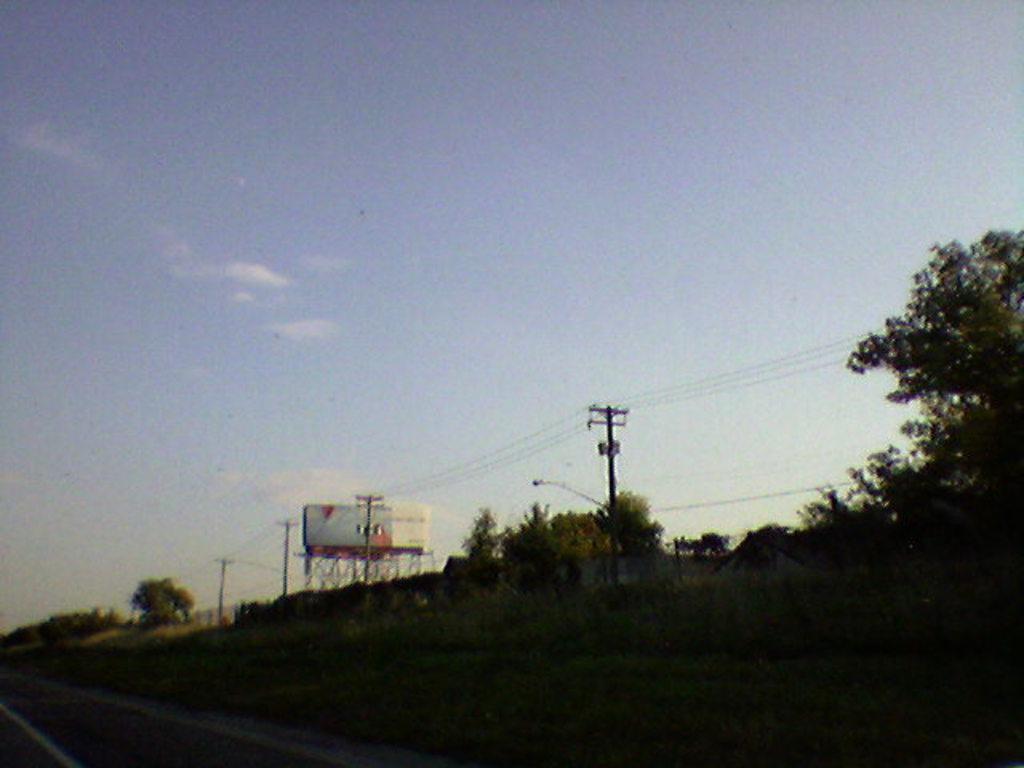What type of vegetation can be seen in the image? There are plants and trees in the image. What can be seen in the background of the image? There are poles, wires, and other unspecified objects in the background of the image. What type of juice is being served in the image? There is no juice present in the image. What subject is being taught in the image? There is no teaching or educational activity depicted in the image. 